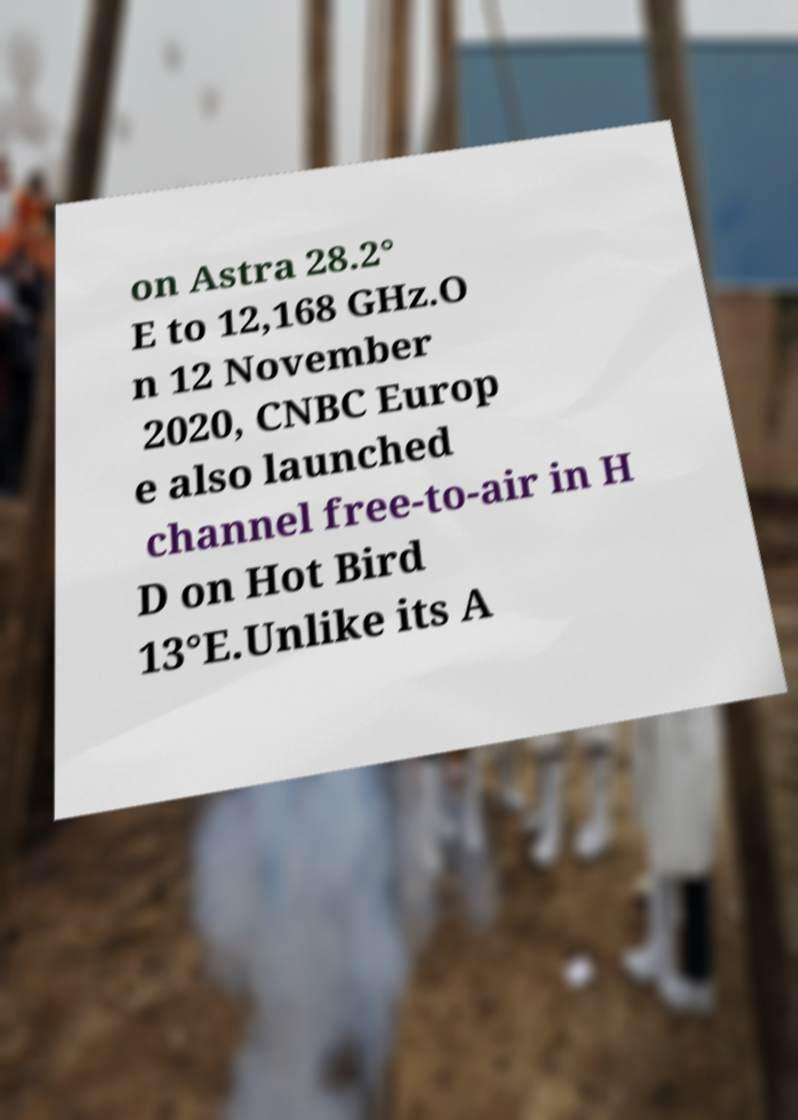There's text embedded in this image that I need extracted. Can you transcribe it verbatim? on Astra 28.2° E to 12,168 GHz.O n 12 November 2020, CNBC Europ e also launched channel free-to-air in H D on Hot Bird 13°E.Unlike its A 